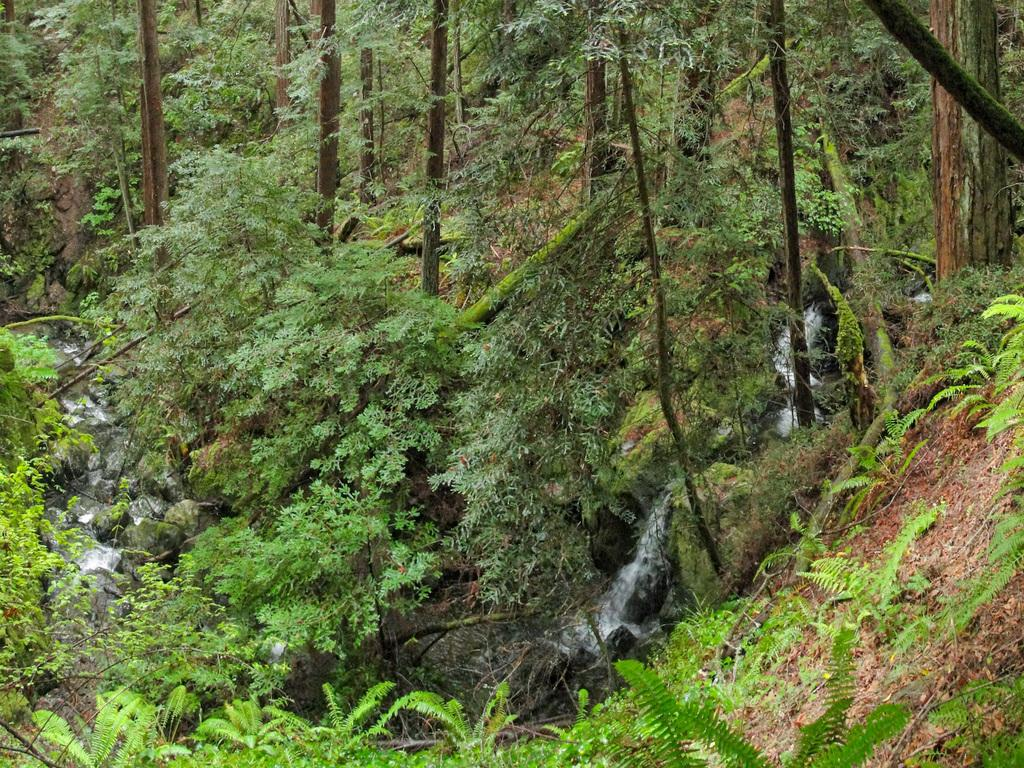What type of vegetation can be seen in the image? There are trees in the image. What natural element is visible in the image besides the trees? There is water visible in the image. What type of material is present in the image? There are stones in the image. How many cacti can be seen on the island in the image? There is no island or cactus present in the image. What is in the pocket of the person in the image? There is no person or pocket present in the image. 